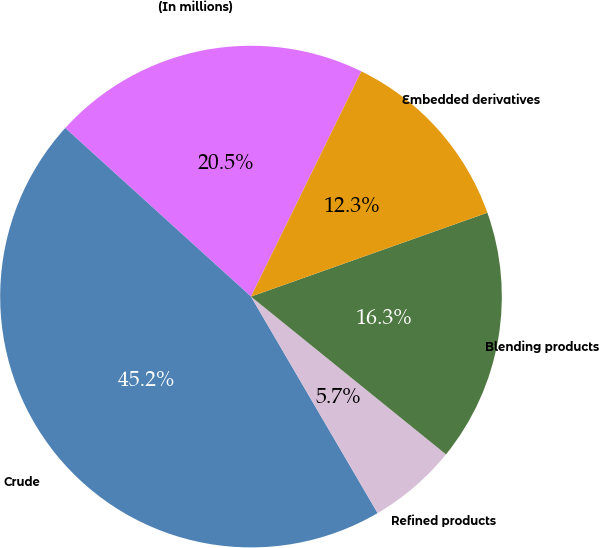Convert chart to OTSL. <chart><loc_0><loc_0><loc_500><loc_500><pie_chart><fcel>(In millions)<fcel>Crude<fcel>Refined products<fcel>Blending products<fcel>Embedded derivatives<nl><fcel>20.53%<fcel>45.16%<fcel>5.75%<fcel>16.26%<fcel>12.32%<nl></chart> 